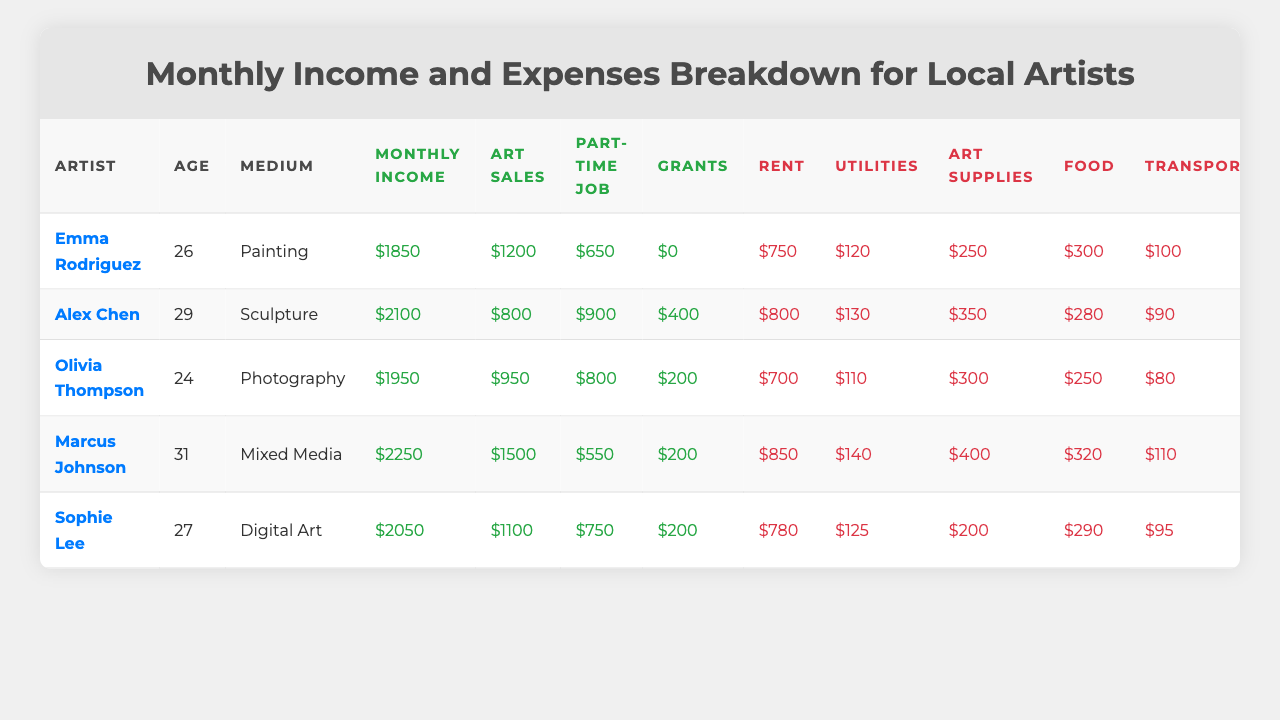What is Emma Rodriguez's monthly income? Emma's monthly income is a specific value listed in the table right under her name in the 'Monthly Income' column. The table shows her monthly income as $1850.
Answer: $1850 How much does Alex Chen spend on rent? Alex’s rent expense is listed directly in the 'Rent' column next to his name in the table. According to the table, his rent is $800.
Answer: $800 Who has the highest art sales? To determine the highest art sales, we need to compare the 'Art Sales' values for each artist. Marcus Johnson has the highest sales at $1500.
Answer: Marcus Johnson What is the total monthly income for all artists combined? To find the total monthly income, add all the artists' monthly incomes together: $1850 + $2100 + $1950 + $2250 + $2050 = $10200.
Answer: $10200 What percentage of Olivia Thompson's income comes from art sales? First, identify Olivia's art sales ($950) and monthly income ($1950). Then, calculate the percentage: (950/1950) * 100 = approximately 48.72%.
Answer: 48.72% Which artist has the highest total expenses? To find the artist with the highest expenses, we must sum the expense categories for each artist and compare them. Marcus Johnson's total expenses are the highest at $2680.
Answer: Marcus Johnson Are any artists saving money? To determine if artists are saving, look at the 'Savings' column. All artists have positive savings values except for those whose savings are not listed with zero or negative values, confirming they all save.
Answer: Yes What is the average rent cost among all artists? Calculate the average rent by summing all rent costs ($750 + $800 + $700 + $850 + $780) = $3930, then divide by the number of artists (5): $3930 / 5 = $786.
Answer: $786 Does Sophie Lee have more expenses than she earns? Compare Sophie’s total income ($2050) to her expenses by summing all her expenses. Her total expenses amount to $1815. Since $2050 is greater than $1815, she earns more.
Answer: No Which medium has the lowest average income among the artists? Calculate the average income for each medium using the monthly incomes and count the number of artists per medium: Painting = $1850, Sculpture = $2100, Photography = $1950, Mixed Media = $2250, Digital Art = $2050. The lowest average income is Painting at $1850.
Answer: Painting 